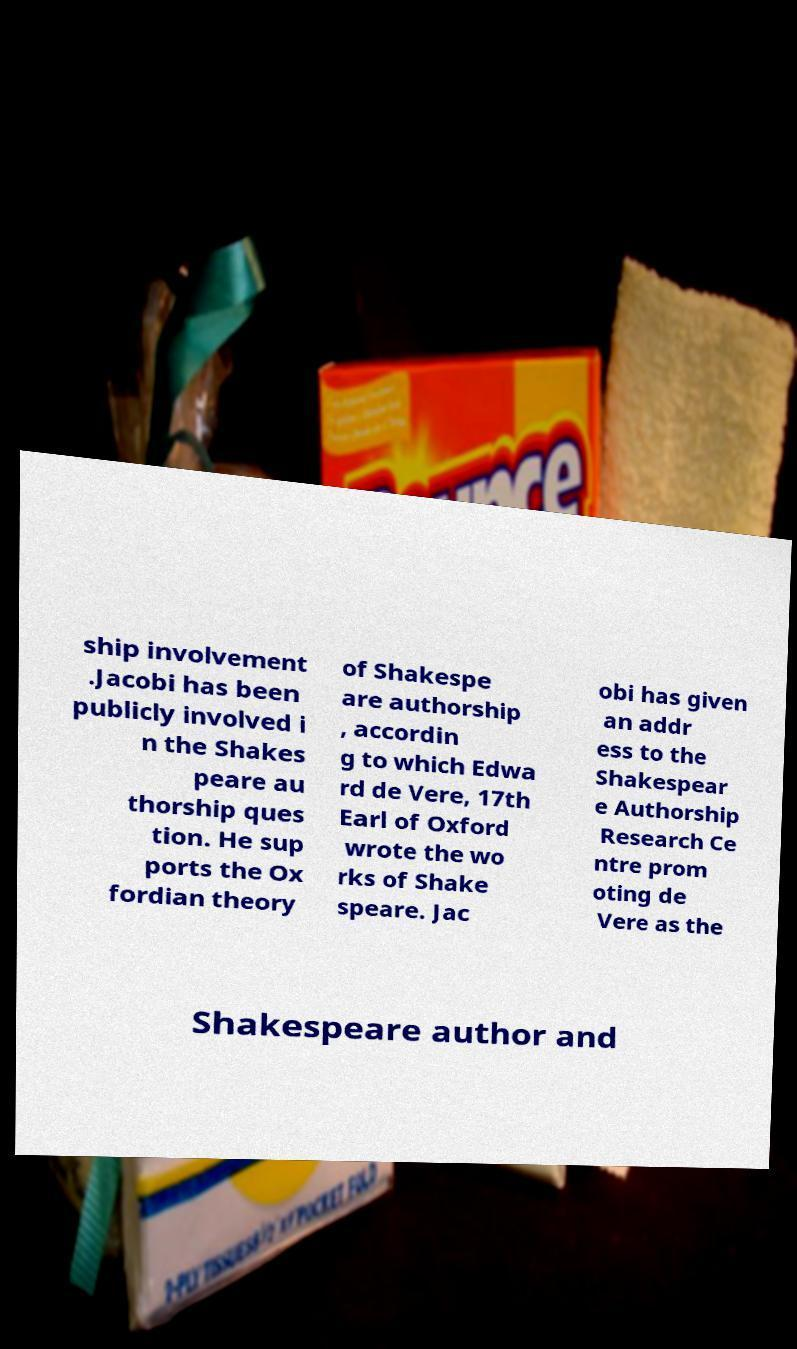I need the written content from this picture converted into text. Can you do that? ship involvement .Jacobi has been publicly involved i n the Shakes peare au thorship ques tion. He sup ports the Ox fordian theory of Shakespe are authorship , accordin g to which Edwa rd de Vere, 17th Earl of Oxford wrote the wo rks of Shake speare. Jac obi has given an addr ess to the Shakespear e Authorship Research Ce ntre prom oting de Vere as the Shakespeare author and 